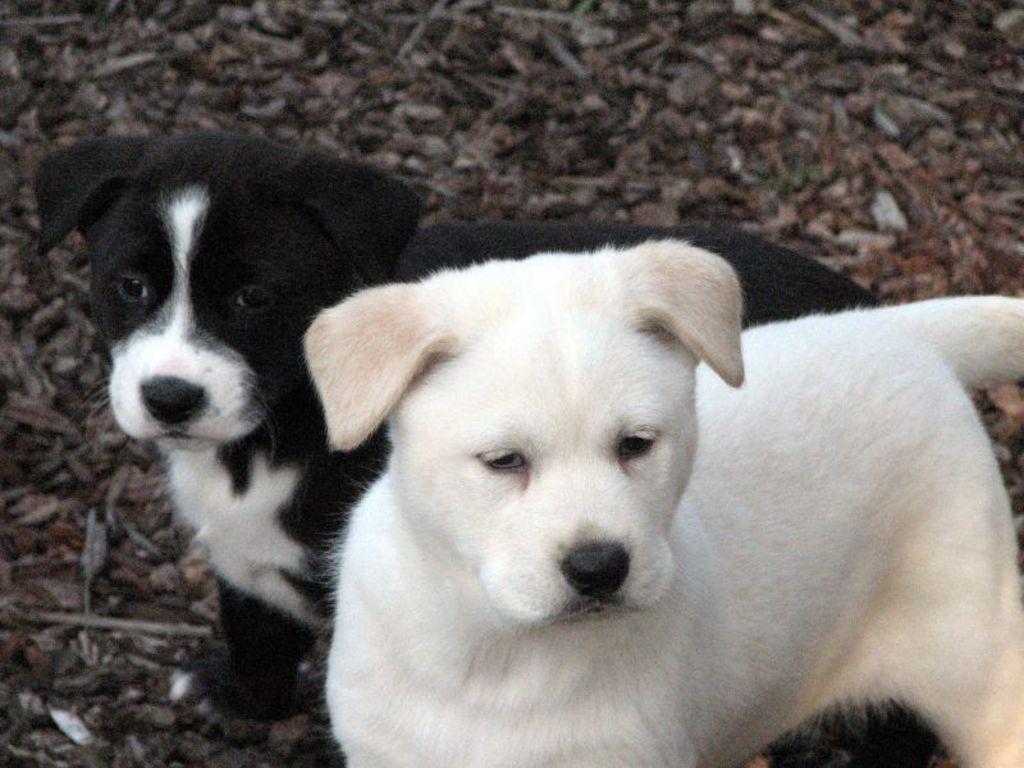How would you summarize this image in a sentence or two? In the foreground of the picture there are dogs and stones. At the top there are stones. 